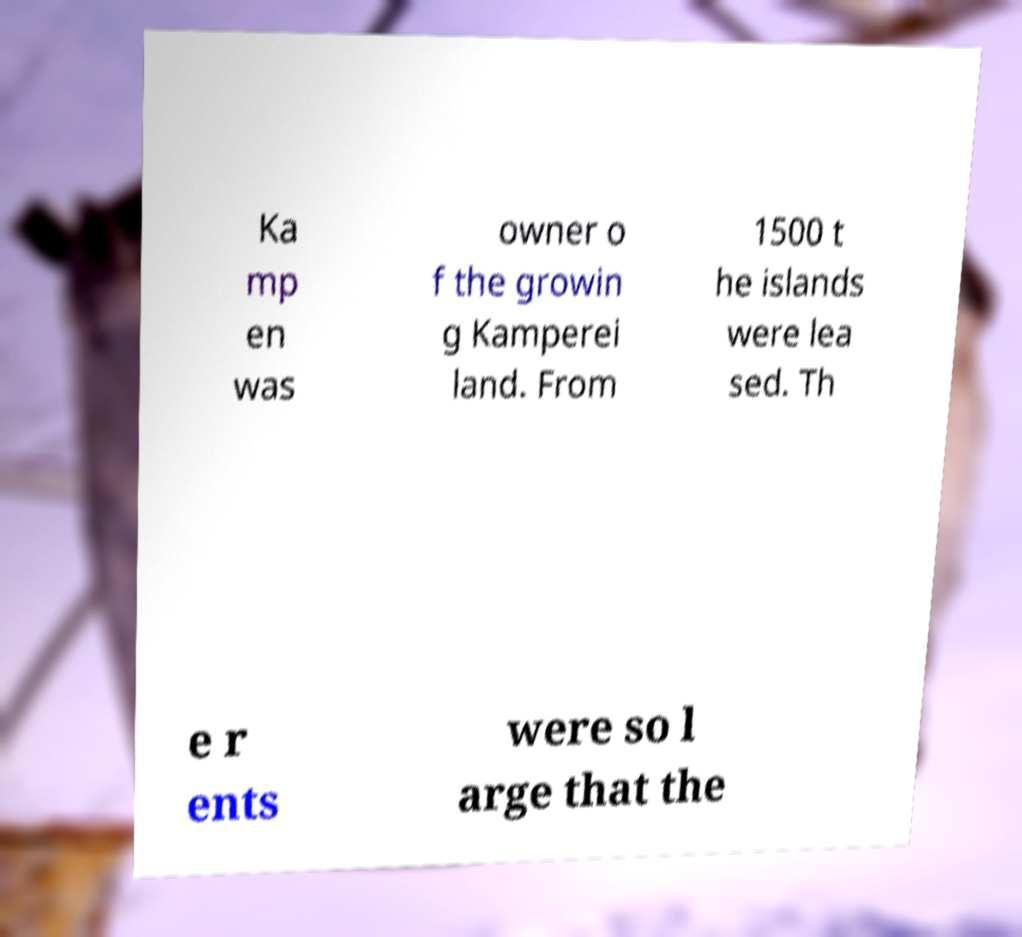For documentation purposes, I need the text within this image transcribed. Could you provide that? Ka mp en was owner o f the growin g Kamperei land. From 1500 t he islands were lea sed. Th e r ents were so l arge that the 